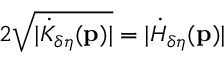<formula> <loc_0><loc_0><loc_500><loc_500>2 \sqrt { | \dot { K } _ { \delta \eta } ( p ) | } = | \dot { H } _ { \delta \eta } ( p ) |</formula> 